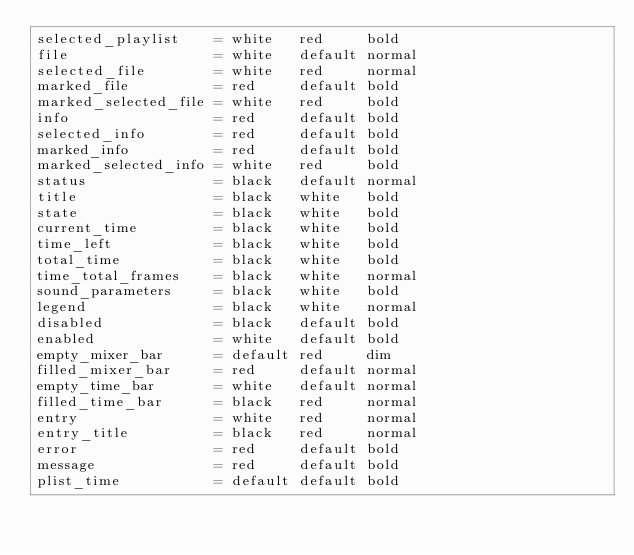<code> <loc_0><loc_0><loc_500><loc_500><_SML_>selected_playlist    = white   red     bold
file                 = white   default normal
selected_file        = white   red     normal
marked_file          = red     default bold
marked_selected_file = white   red     bold
info                 = red     default bold
selected_info        = red     default bold
marked_info          = red     default bold
marked_selected_info = white   red     bold
status               = black   default normal
title                = black   white   bold
state                = black   white   bold
current_time         = black   white   bold
time_left            = black   white   bold
total_time           = black   white   bold
time_total_frames    = black   white   normal
sound_parameters     = black   white   bold
legend               = black   white   normal
disabled             = black   default bold
enabled              = white   default bold
empty_mixer_bar      = default red     dim
filled_mixer_bar     = red     default normal
empty_time_bar       = white   default normal
filled_time_bar      = black   red     normal
entry                = white   red     normal
entry_title          = black   red     normal
error                = red     default bold
message              = red     default bold
plist_time           = default default bold
</code> 